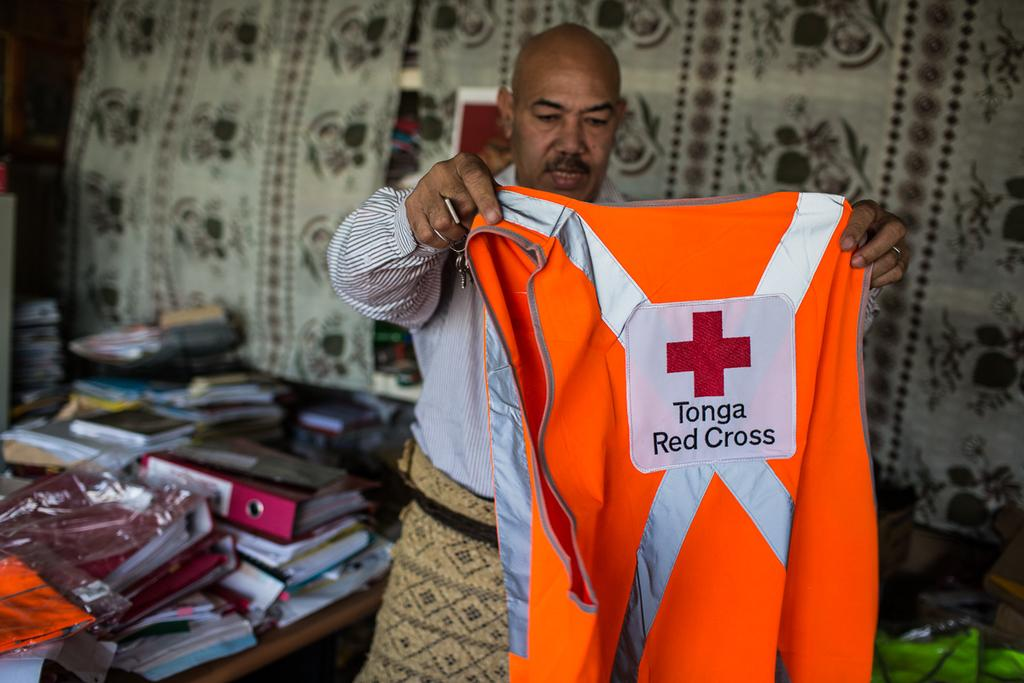Provide a one-sentence caption for the provided image. A man holds up an orange safety vest for Tonga Red Cross. 